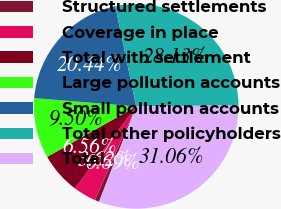Convert chart to OTSL. <chart><loc_0><loc_0><loc_500><loc_500><pie_chart><fcel>Structured settlements<fcel>Coverage in place<fcel>Total with settlement<fcel>Large pollution accounts<fcel>Small pollution accounts<fcel>Total other policyholders<fcel>Total<nl><fcel>0.69%<fcel>3.62%<fcel>6.56%<fcel>9.5%<fcel>20.44%<fcel>28.13%<fcel>31.06%<nl></chart> 